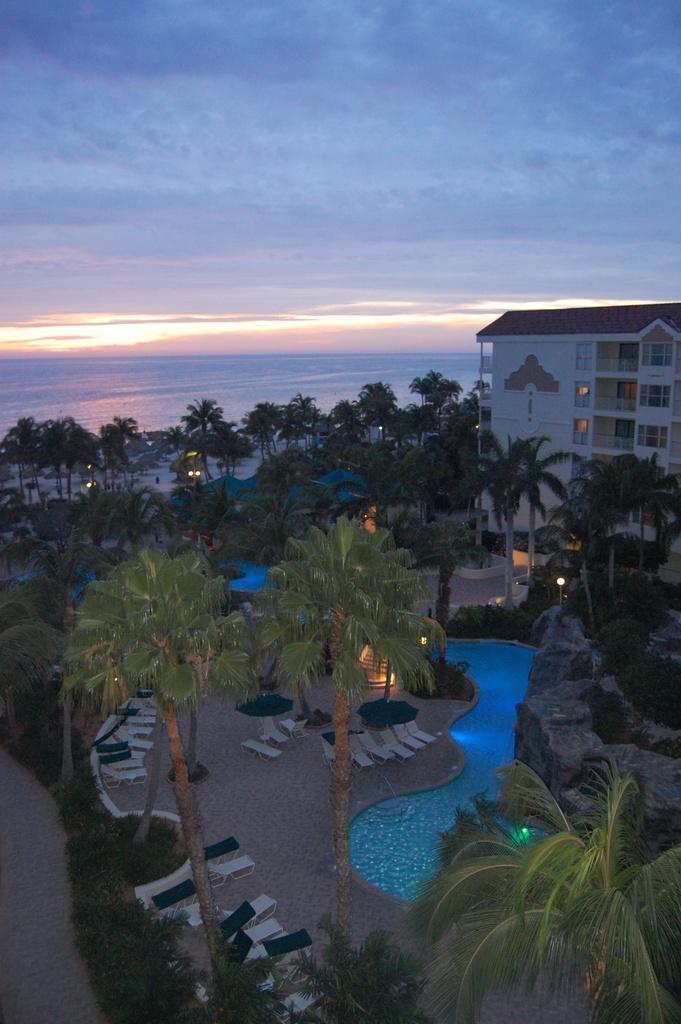Can you describe this image briefly? In the foreground I can see grass, plants, trees, beds, swimming pool and lights. In the background I can see a building and the sky. This image is taken may be near the building. 